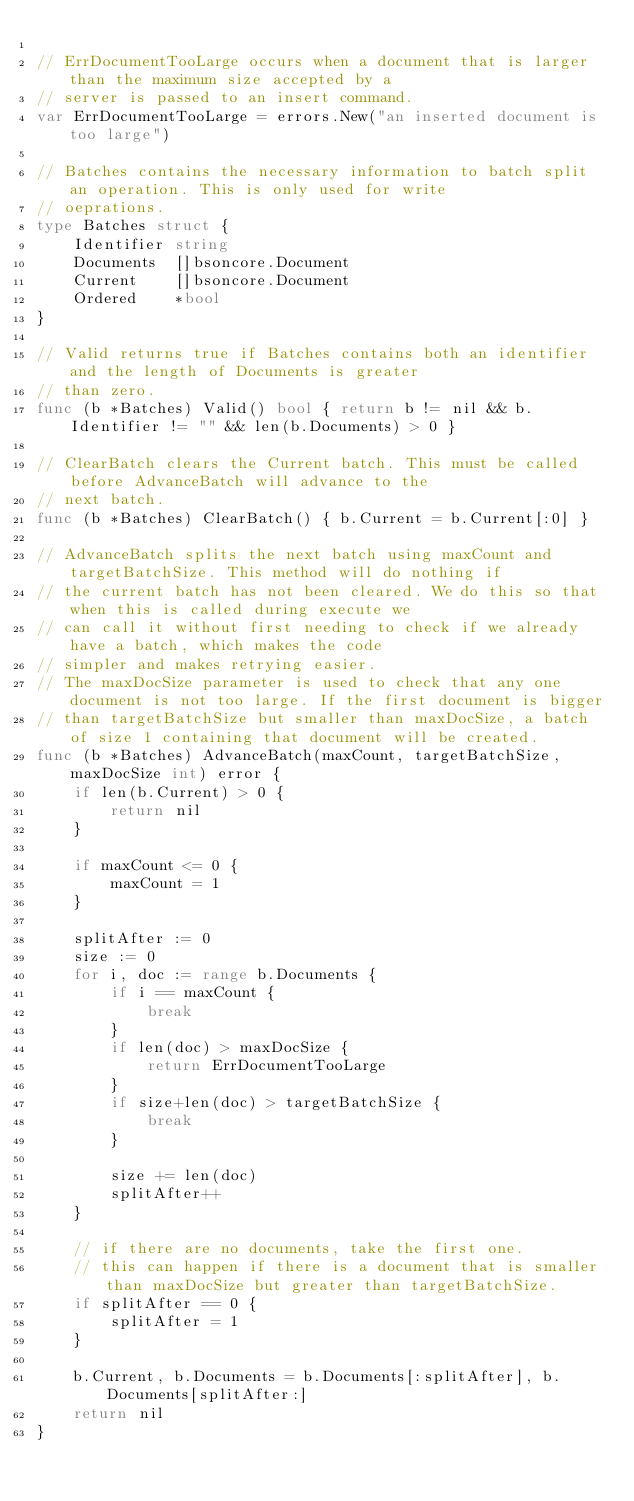<code> <loc_0><loc_0><loc_500><loc_500><_Go_>
// ErrDocumentTooLarge occurs when a document that is larger than the maximum size accepted by a
// server is passed to an insert command.
var ErrDocumentTooLarge = errors.New("an inserted document is too large")

// Batches contains the necessary information to batch split an operation. This is only used for write
// oeprations.
type Batches struct {
	Identifier string
	Documents  []bsoncore.Document
	Current    []bsoncore.Document
	Ordered    *bool
}

// Valid returns true if Batches contains both an identifier and the length of Documents is greater
// than zero.
func (b *Batches) Valid() bool { return b != nil && b.Identifier != "" && len(b.Documents) > 0 }

// ClearBatch clears the Current batch. This must be called before AdvanceBatch will advance to the
// next batch.
func (b *Batches) ClearBatch() { b.Current = b.Current[:0] }

// AdvanceBatch splits the next batch using maxCount and targetBatchSize. This method will do nothing if
// the current batch has not been cleared. We do this so that when this is called during execute we
// can call it without first needing to check if we already have a batch, which makes the code
// simpler and makes retrying easier.
// The maxDocSize parameter is used to check that any one document is not too large. If the first document is bigger
// than targetBatchSize but smaller than maxDocSize, a batch of size 1 containing that document will be created.
func (b *Batches) AdvanceBatch(maxCount, targetBatchSize, maxDocSize int) error {
	if len(b.Current) > 0 {
		return nil
	}

	if maxCount <= 0 {
		maxCount = 1
	}

	splitAfter := 0
	size := 0
	for i, doc := range b.Documents {
		if i == maxCount {
			break
		}
		if len(doc) > maxDocSize {
			return ErrDocumentTooLarge
		}
		if size+len(doc) > targetBatchSize {
			break
		}

		size += len(doc)
		splitAfter++
	}

	// if there are no documents, take the first one.
	// this can happen if there is a document that is smaller than maxDocSize but greater than targetBatchSize.
	if splitAfter == 0 {
		splitAfter = 1
	}

	b.Current, b.Documents = b.Documents[:splitAfter], b.Documents[splitAfter:]
	return nil
}
</code> 